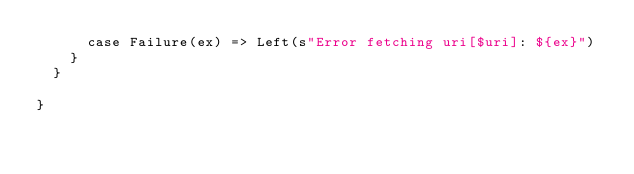<code> <loc_0><loc_0><loc_500><loc_500><_Scala_>      case Failure(ex) => Left(s"Error fetching uri[$uri]: ${ex}")
    }
  }

}
</code> 